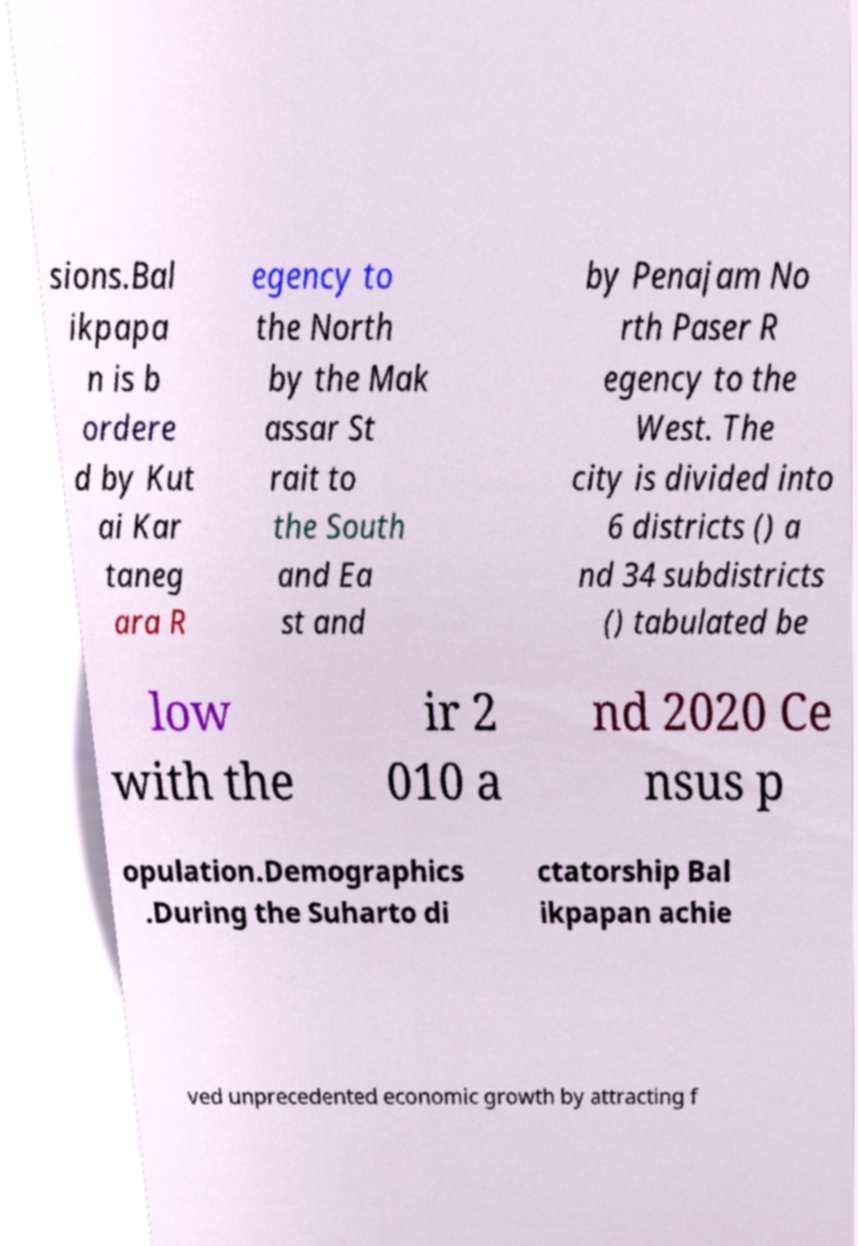For documentation purposes, I need the text within this image transcribed. Could you provide that? sions.Bal ikpapa n is b ordere d by Kut ai Kar taneg ara R egency to the North by the Mak assar St rait to the South and Ea st and by Penajam No rth Paser R egency to the West. The city is divided into 6 districts () a nd 34 subdistricts () tabulated be low with the ir 2 010 a nd 2020 Ce nsus p opulation.Demographics .During the Suharto di ctatorship Bal ikpapan achie ved unprecedented economic growth by attracting f 